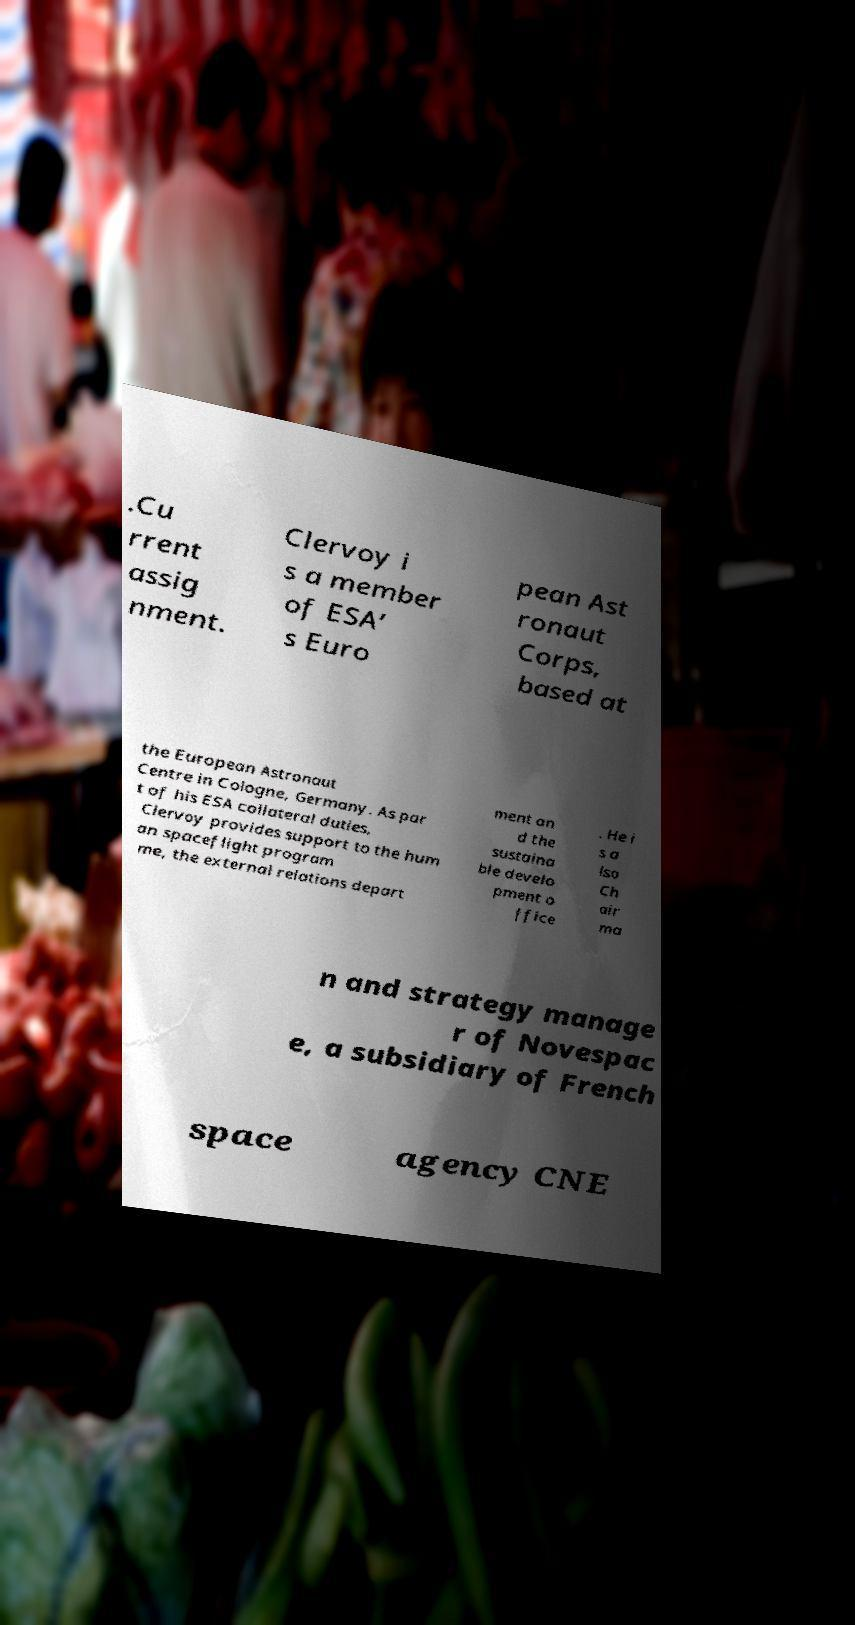I need the written content from this picture converted into text. Can you do that? .Cu rrent assig nment. Clervoy i s a member of ESA’ s Euro pean Ast ronaut Corps, based at the European Astronaut Centre in Cologne, Germany. As par t of his ESA collateral duties, Clervoy provides support to the hum an spaceflight program me, the external relations depart ment an d the sustaina ble develo pment o ffice . He i s a lso Ch air ma n and strategy manage r of Novespac e, a subsidiary of French space agency CNE 